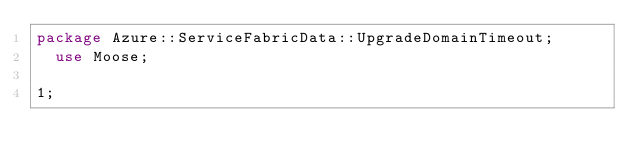Convert code to text. <code><loc_0><loc_0><loc_500><loc_500><_Perl_>package Azure::ServiceFabricData::UpgradeDomainTimeout;
  use Moose;

1;
</code> 